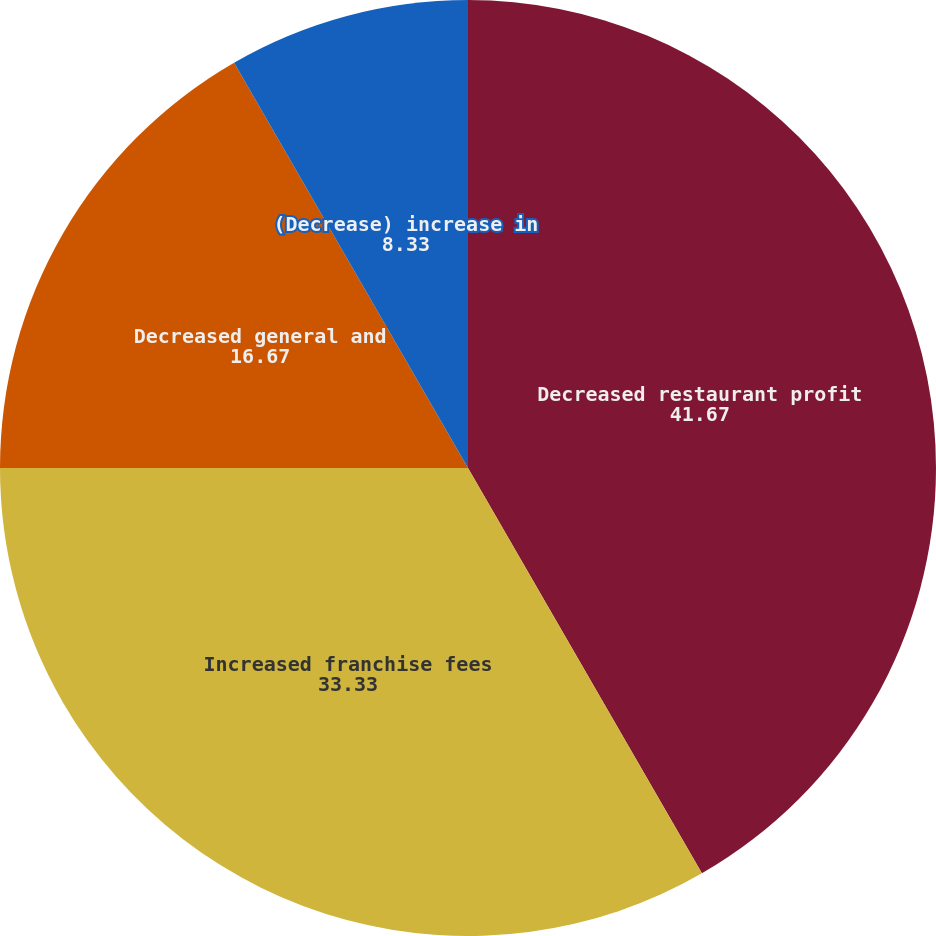Convert chart. <chart><loc_0><loc_0><loc_500><loc_500><pie_chart><fcel>Decreased restaurant profit<fcel>Increased franchise fees<fcel>Decreased general and<fcel>(Decrease) increase in<nl><fcel>41.67%<fcel>33.33%<fcel>16.67%<fcel>8.33%<nl></chart> 